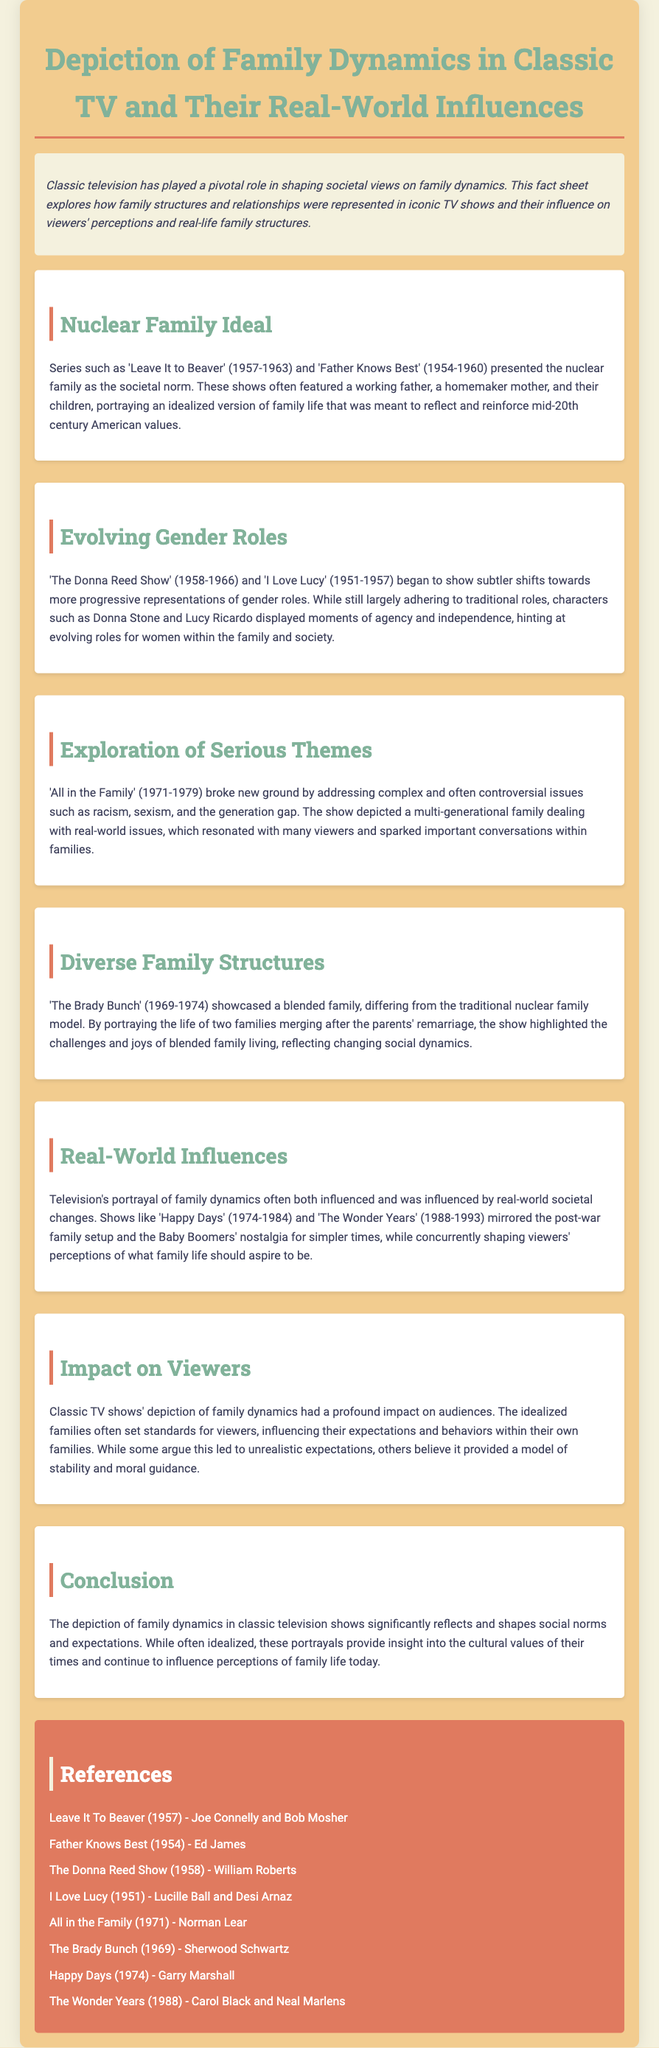What shows depicted the nuclear family ideal? The document lists 'Leave It to Beaver' and 'Father Knows Best' as shows that depicted the nuclear family ideal.
Answer: 'Leave It to Beaver', 'Father Knows Best' What years did 'The Donna Reed Show' air? The document states that 'The Donna Reed Show' aired from 1958 to 1966.
Answer: 1958-1966 Which show broke new ground by addressing complex issues? According to the document, 'All in the Family' broke new ground by addressing complex issues.
Answer: 'All in the Family' What family structure did 'The Brady Bunch' showcase? The document indicates that 'The Brady Bunch' showcased a blended family structure.
Answer: Blended family How did classic TV shows influence viewers' expectations? The document mentions that classic TV shows' depictions of family dynamics often set standards for viewers, influencing their expectations and behaviors.
Answer: Set standards for viewers Which show mirrored Baby Boomers' nostalgia? The document states that 'The Wonder Years' mirrored Baby Boomers' nostalgia for simpler times.
Answer: 'The Wonder Years' What is the main conclusion of the document? The conclusion states that the depiction of family dynamics in classic television reflects and shapes social norms and expectations.
Answer: Reflects and shapes social norms Who created 'I Love Lucy'? The document mentions that 'I Love Lucy' was created by Lucille Ball and Desi Arnaz.
Answer: Lucille Ball and Desi Arnaz What color is used in the document's references section? The document describes the references section as having a background color of #e07a5f.
Answer: #e07a5f 